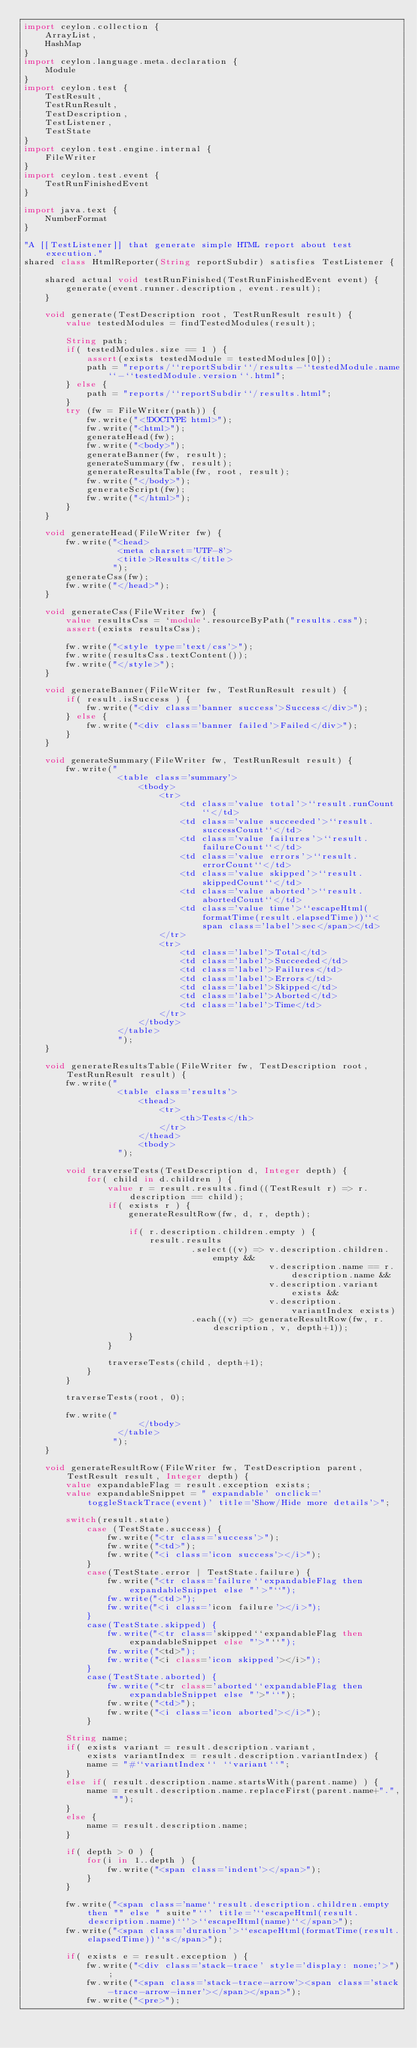<code> <loc_0><loc_0><loc_500><loc_500><_Ceylon_>import ceylon.collection {
    ArrayList,
    HashMap
}
import ceylon.language.meta.declaration {
    Module
}
import ceylon.test {
    TestResult,
    TestRunResult,
    TestDescription,
    TestListener,
    TestState
}
import ceylon.test.engine.internal {
    FileWriter
}
import ceylon.test.event {
    TestRunFinishedEvent
}

import java.text {
    NumberFormat
}

"A [[TestListener]] that generate simple HTML report about test execution."
shared class HtmlReporter(String reportSubdir) satisfies TestListener {
    
    shared actual void testRunFinished(TestRunFinishedEvent event) {
        generate(event.runner.description, event.result);
    }
    
    void generate(TestDescription root, TestRunResult result) {
        value testedModules = findTestedModules(result);
        
        String path;
        if( testedModules.size == 1 ) {
            assert(exists testedModule = testedModules[0]);
            path = "reports/``reportSubdir``/results-``testedModule.name``-``testedModule.version``.html";
        } else {
            path = "reports/``reportSubdir``/results.html";
        }
        try (fw = FileWriter(path)) {
            fw.write("<!DOCTYPE html>");
            fw.write("<html>");
            generateHead(fw);
            fw.write("<body>");
            generateBanner(fw, result);
            generateSummary(fw, result);
            generateResultsTable(fw, root, result);
            fw.write("</body>");
            generateScript(fw);
            fw.write("</html>");
        }
    }
    
    void generateHead(FileWriter fw) {
        fw.write("<head>
                  <meta charset='UTF-8'>
                  <title>Results</title>
                 ");
        generateCss(fw);
        fw.write("</head>");
    }
    
    void generateCss(FileWriter fw) {
        value resultsCss = `module`.resourceByPath("results.css");
        assert(exists resultsCss);
        
        fw.write("<style type='text/css'>");
        fw.write(resultsCss.textContent());
        fw.write("</style>");
    }
    
    void generateBanner(FileWriter fw, TestRunResult result) {
        if( result.isSuccess ) {
            fw.write("<div class='banner success'>Success</div>");
        } else {
            fw.write("<div class='banner failed'>Failed</div>");
        }
    }
    
    void generateSummary(FileWriter fw, TestRunResult result) {
        fw.write("
                  <table class='summary'>
                      <tbody>
                          <tr>
                              <td class='value total'>``result.runCount``</td>
                              <td class='value succeeded'>``result.successCount``</td>
                              <td class='value failures'>``result.failureCount``</td>
                              <td class='value errors'>``result.errorCount``</td>
                              <td class='value skipped'>``result.skippedCount``</td>
                              <td class='value aborted'>``result.abortedCount``</td>
                              <td class='value time'>``escapeHtml(formatTime(result.elapsedTime))``<span class='label'>sec</span></td>
                          </tr>
                          <tr>
                              <td class='label'>Total</td>
                              <td class='label'>Succeeded</td>
                              <td class='label'>Failures</td>
                              <td class='label'>Errors</td>
                              <td class='label'>Skipped</td>
                              <td class='label'>Aborted</td>
                              <td class='label'>Time</td>
                          </tr>
                      </tbody>
                  </table>
                  ");
    }
    
    void generateResultsTable(FileWriter fw, TestDescription root, TestRunResult result) {
        fw.write("
                  <table class='results'>
                      <thead>
                          <tr>
                              <th>Tests</th>
                          </tr>
                      </thead>
                      <tbody>
                  ");
        
        void traverseTests(TestDescription d, Integer depth) {
            for( child in d.children ) {
                value r = result.results.find((TestResult r) => r.description == child);
                if( exists r ) {
                    generateResultRow(fw, d, r, depth);
                    
                    if( r.description.children.empty ) {
                        result.results
                                .select((v) => v.description.children.empty &&
                                               v.description.name == r.description.name &&
                                               v.description.variant exists &&
                                               v.description.variantIndex exists)
                                .each((v) => generateResultRow(fw, r.description, v, depth+1));
                    }
                }
                
                traverseTests(child, depth+1);
            }
        }
        
        traverseTests(root, 0);
        
        fw.write("
                      </tbody>
                  </table>
                 ");
    }
    
    void generateResultRow(FileWriter fw, TestDescription parent, TestResult result, Integer depth) {
        value expandableFlag = result.exception exists;
        value expandableSnippet = " expandable' onclick='toggleStackTrace(event)' title='Show/Hide more details'>";
        
        switch(result.state)
            case (TestState.success) {
                fw.write("<tr class='success'>");
                fw.write("<td>");
                fw.write("<i class='icon success'></i>");
            }
            case(TestState.error | TestState.failure) {
                fw.write("<tr class='failure``expandableFlag then expandableSnippet else "'>"``");
                fw.write("<td>");
                fw.write("<i class='icon failure'></i>");
            }
            case(TestState.skipped) {
                fw.write("<tr class='skipped``expandableFlag then expandableSnippet else "'>"``");
                fw.write("<td>");
                fw.write("<i class='icon skipped'></i>");
            }
            case(TestState.aborted) {
                fw.write("<tr class='aborted``expandableFlag then expandableSnippet else "'>"``");
                fw.write("<td>");
                fw.write("<i class='icon aborted'></i>");
            }

        String name;
        if( exists variant = result.description.variant,
            exists variantIndex = result.description.variantIndex) {
            name = "#``variantIndex`` ``variant``";
        }
        else if( result.description.name.startsWith(parent.name) ) {
            name = result.description.name.replaceFirst(parent.name+".", "");
        }
        else {
            name = result.description.name;
        }
        
        if( depth > 0 ) {
            for(i in 1..depth ) {
                fw.write("<span class='indent'></span>");
            }
        }
        
        fw.write("<span class='name``result.description.children.empty then "" else " suite"``' title='``escapeHtml(result.description.name)``'>``escapeHtml(name)``</span>");
        fw.write("<span class='duration'>``escapeHtml(formatTime(result.elapsedTime))``s</span>");
        
        if( exists e = result.exception ) {
            fw.write("<div class='stack-trace' style='display: none;'>");
            fw.write("<span class='stack-trace-arrow'><span class='stack-trace-arrow-inner'></span></span>");
            fw.write("<pre>");</code> 